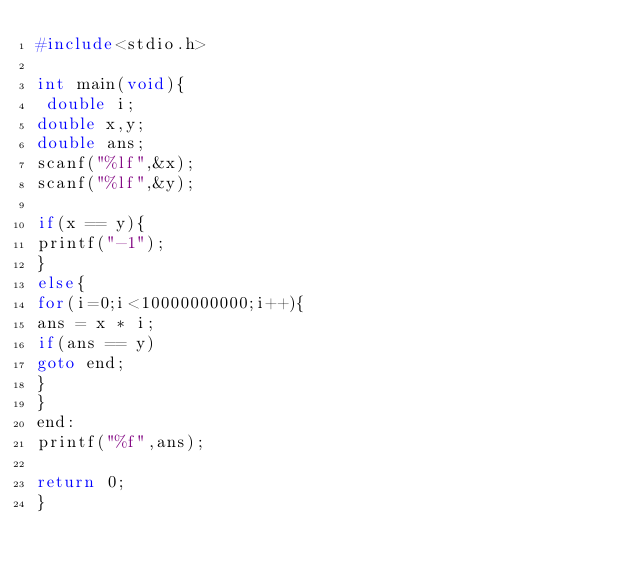Convert code to text. <code><loc_0><loc_0><loc_500><loc_500><_C_>#include<stdio.h>
 
int main(void){
 double i;
double x,y;
double ans;
scanf("%lf",&x);
scanf("%lf",&y);
 
if(x == y){
printf("-1");
}
else{
for(i=0;i<10000000000;i++){
ans = x * i;
if(ans == y)
goto end;
}
}
end:
printf("%f",ans);
 
return 0;
}</code> 